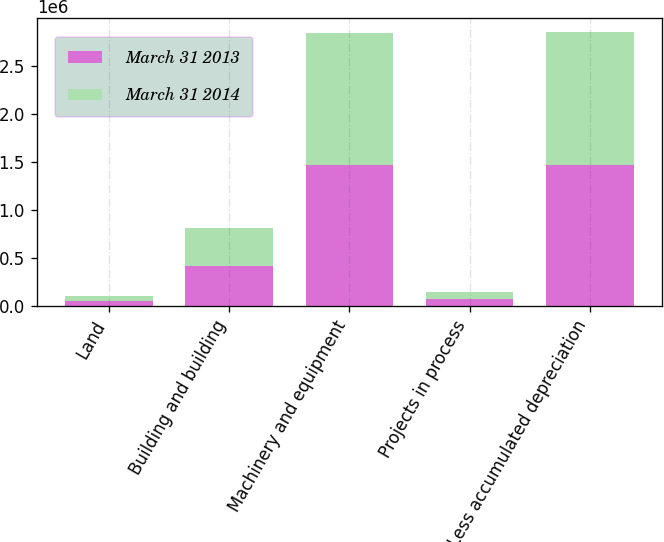Convert chart to OTSL. <chart><loc_0><loc_0><loc_500><loc_500><stacked_bar_chart><ecel><fcel>Land<fcel>Building and building<fcel>Machinery and equipment<fcel>Projects in process<fcel>Less accumulated depreciation<nl><fcel>March 31 2013<fcel>55624<fcel>411149<fcel>1.46526e+06<fcel>68991<fcel>1.46905e+06<nl><fcel>March 31 2014<fcel>47102<fcel>396611<fcel>1.37781e+06<fcel>76158<fcel>1.38314e+06<nl></chart> 